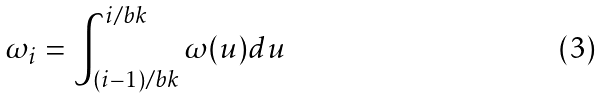Convert formula to latex. <formula><loc_0><loc_0><loc_500><loc_500>\omega _ { i } = \int _ { ( i - 1 ) / b k } ^ { i / b k } \omega ( u ) d u</formula> 